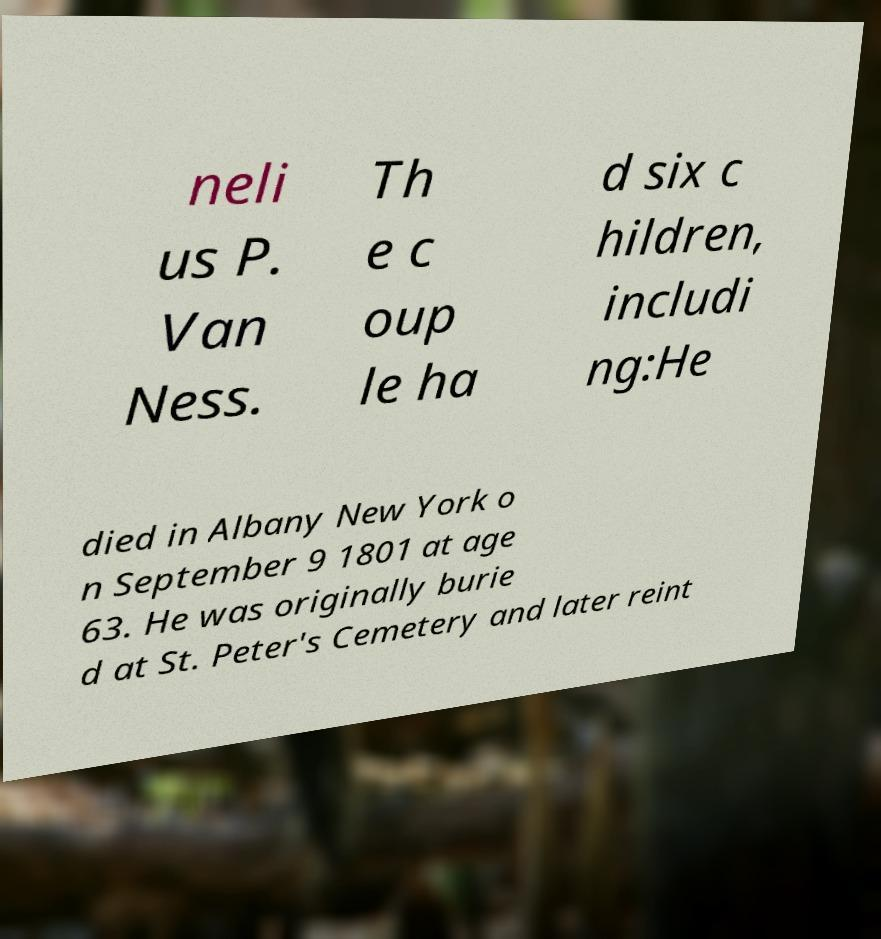Can you read and provide the text displayed in the image?This photo seems to have some interesting text. Can you extract and type it out for me? neli us P. Van Ness. Th e c oup le ha d six c hildren, includi ng:He died in Albany New York o n September 9 1801 at age 63. He was originally burie d at St. Peter's Cemetery and later reint 